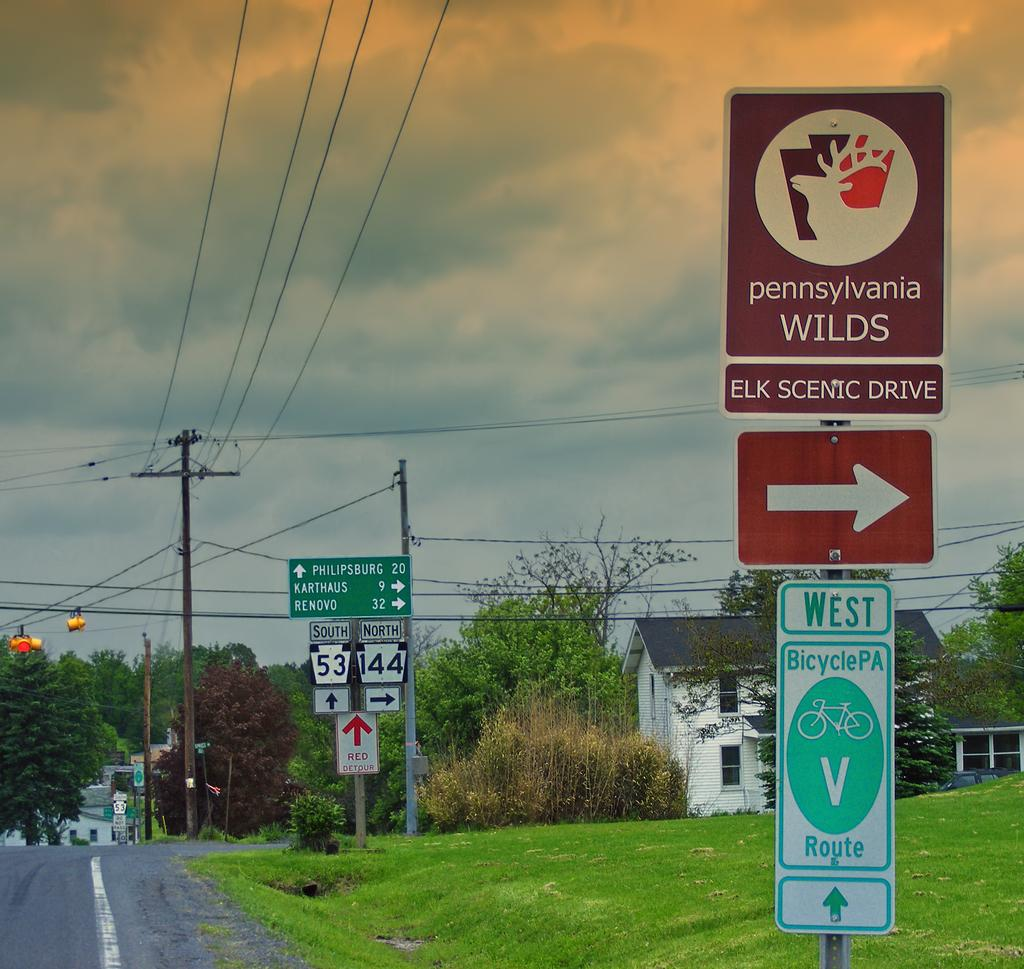<image>
Present a compact description of the photo's key features. A bunch of road signs that show the way to the Pennsylvania Wilds. 